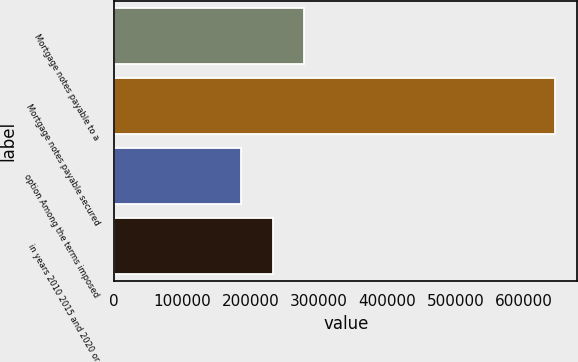Convert chart to OTSL. <chart><loc_0><loc_0><loc_500><loc_500><bar_chart><fcel>Mortgage notes payable to a<fcel>Mortgage notes payable secured<fcel>option Among the terms imposed<fcel>in years 2010 2015 and 2020 or<nl><fcel>278212<fcel>645702<fcel>186339<fcel>232275<nl></chart> 